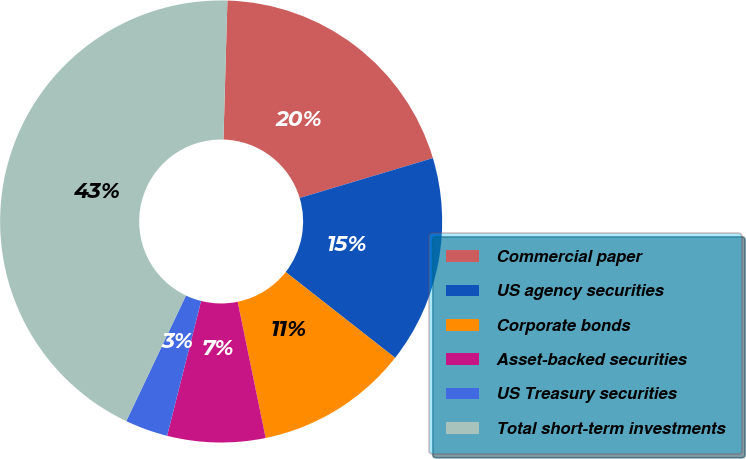<chart> <loc_0><loc_0><loc_500><loc_500><pie_chart><fcel>Commercial paper<fcel>US agency securities<fcel>Corporate bonds<fcel>Asset-backed securities<fcel>US Treasury securities<fcel>Total short-term investments<nl><fcel>19.92%<fcel>15.21%<fcel>11.19%<fcel>7.16%<fcel>3.13%<fcel>43.39%<nl></chart> 